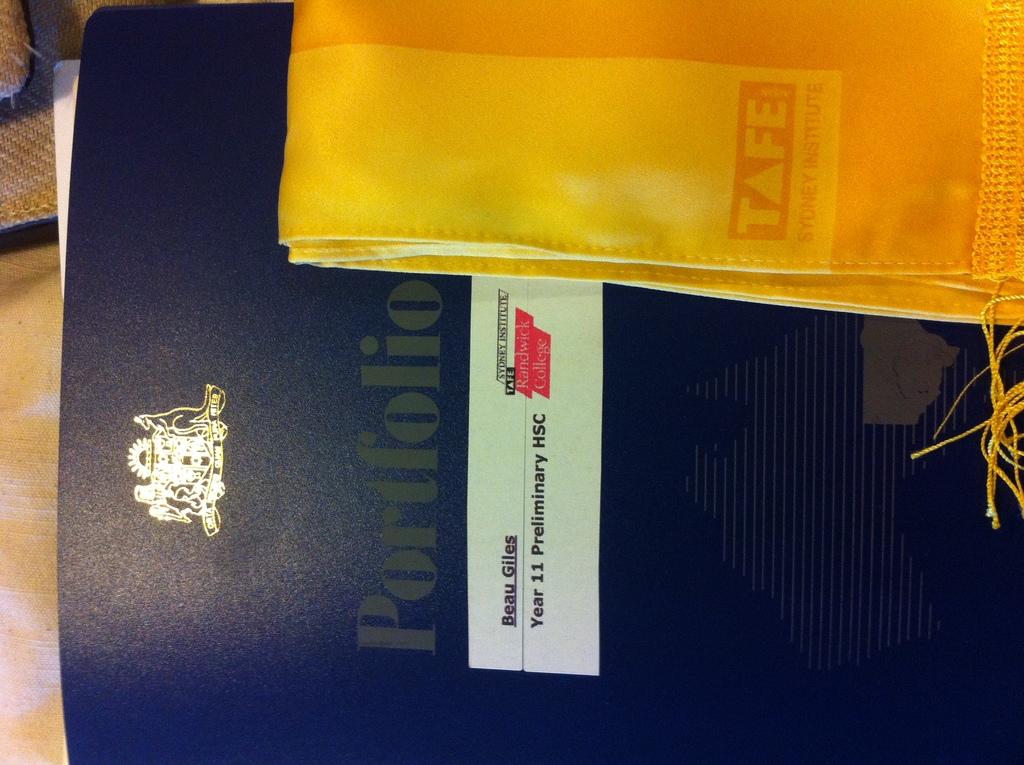Who is the author of this book?
Provide a succinct answer. Beau giles. 